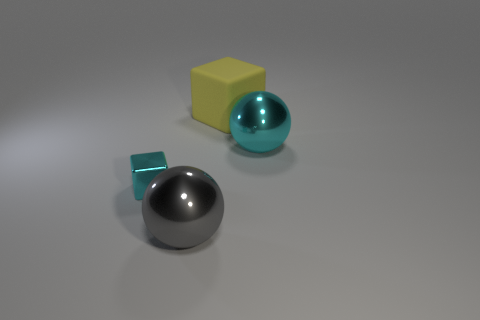Are there any other things that are the same size as the metallic block?
Provide a short and direct response. No. Are there the same number of cyan objects that are to the right of the cyan block and large objects that are behind the cyan ball?
Offer a very short reply. Yes. Are any tiny blue metal spheres visible?
Ensure brevity in your answer.  No. The shiny thing that is the same shape as the yellow rubber object is what size?
Provide a short and direct response. Small. There is a cyan metal object on the left side of the large gray shiny thing; how big is it?
Make the answer very short. Small. Is the number of big objects that are on the right side of the large yellow cube greater than the number of red cylinders?
Your response must be concise. Yes. The tiny cyan metallic thing has what shape?
Ensure brevity in your answer.  Cube. There is a thing that is left of the large gray shiny thing; is its color the same as the large object in front of the large cyan ball?
Make the answer very short. No. Is the shape of the small metal thing the same as the matte thing?
Provide a short and direct response. Yes. Is the sphere that is to the left of the big cyan object made of the same material as the large cyan thing?
Give a very brief answer. Yes. 